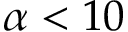<formula> <loc_0><loc_0><loc_500><loc_500>\alpha < 1 0</formula> 